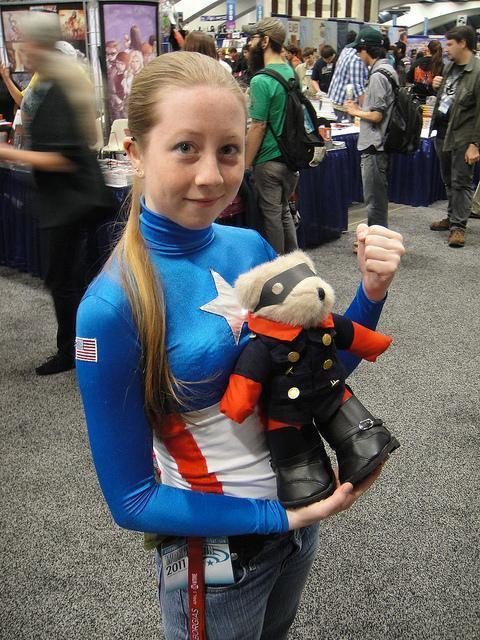In which sort of event does this woman pose?
Choose the right answer and clarify with the format: 'Answer: answer
Rationale: rationale.'
Options: Sale, auction, art musem, expo. Answer: expo.
Rationale: She is dressed up at an expo. 